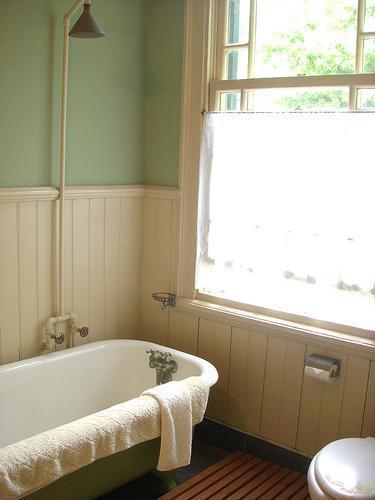How many toilets are there?
Give a very brief answer. 1. 